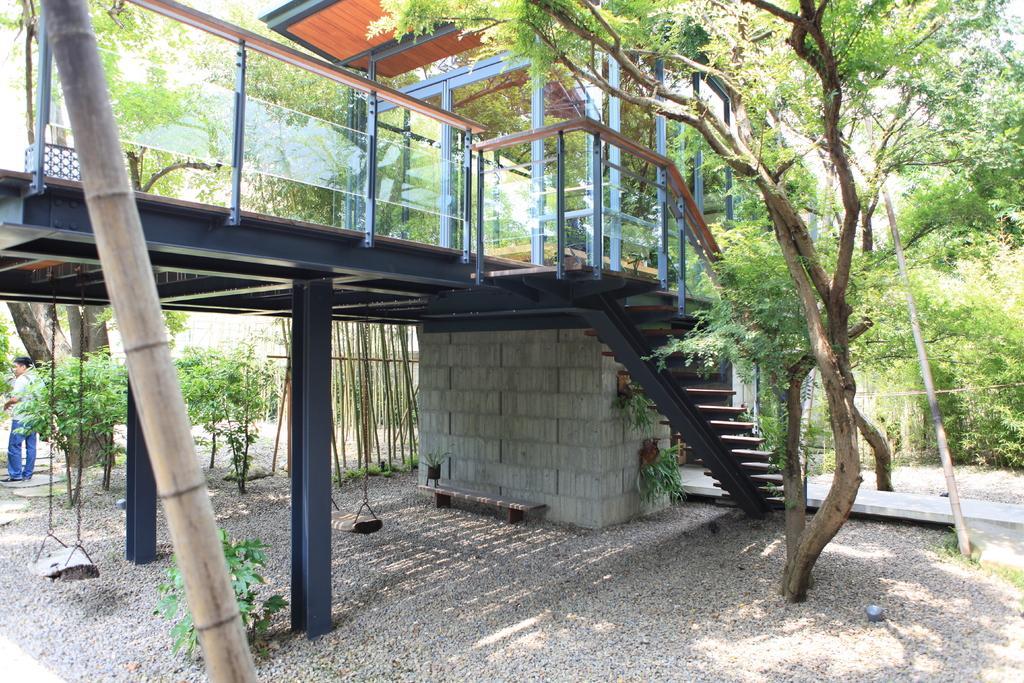Describe this image in one or two sentences. In this image I can see the bridge and the stairs. To the left I can the person standing. I can see the glasses and metal poles. In the background I can see many trees. 